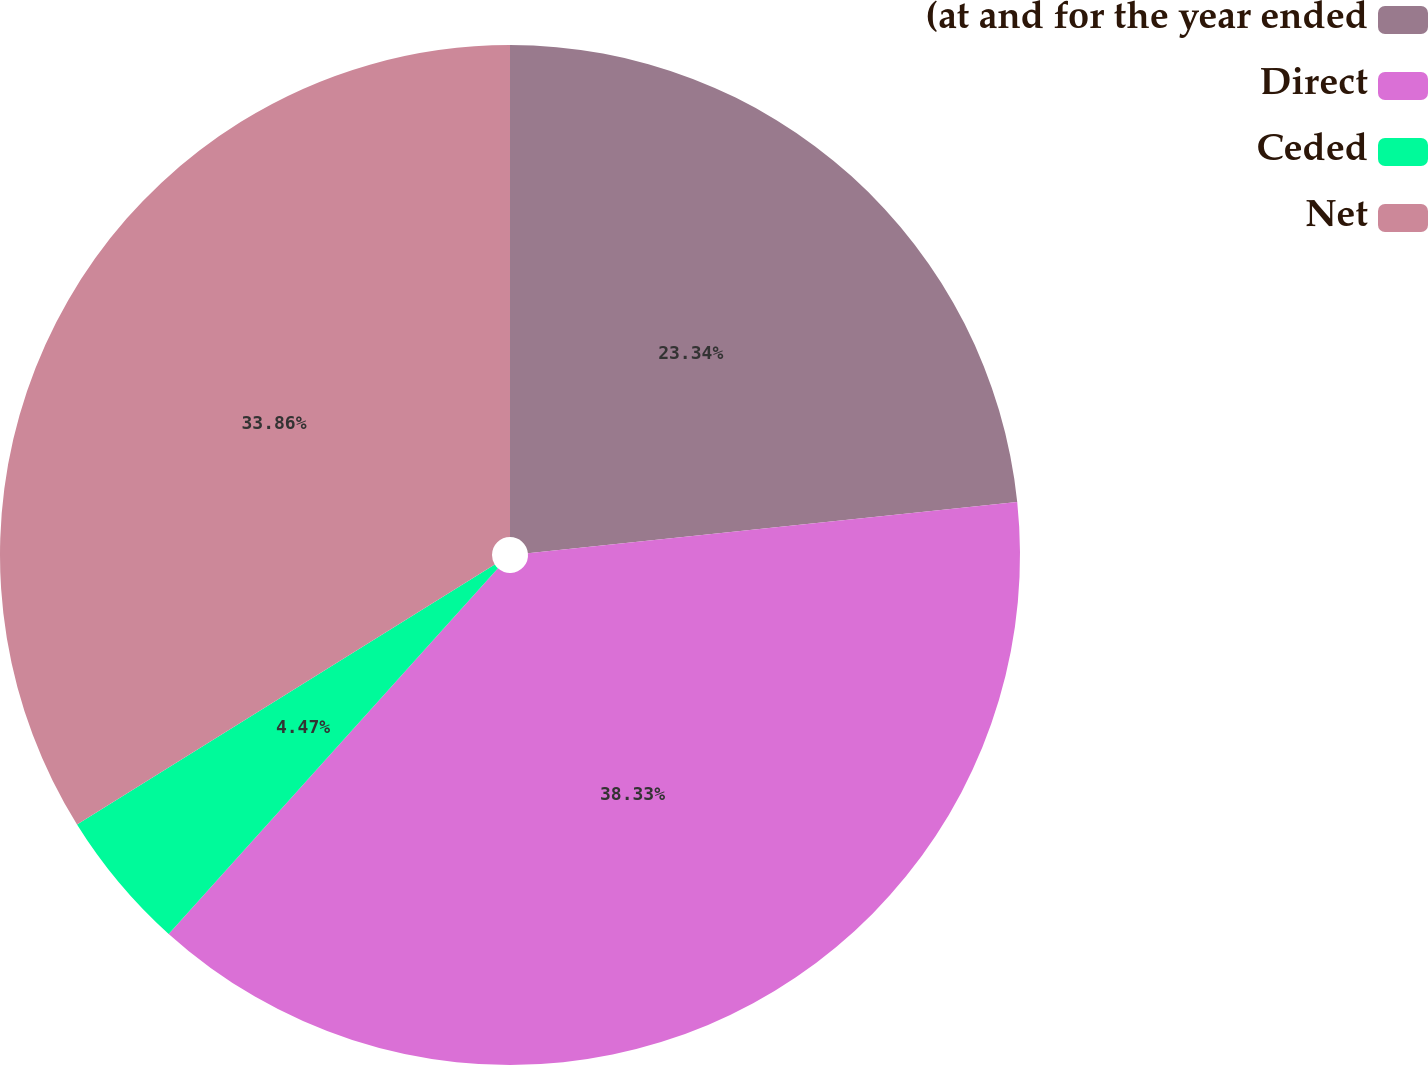Convert chart to OTSL. <chart><loc_0><loc_0><loc_500><loc_500><pie_chart><fcel>(at and for the year ended<fcel>Direct<fcel>Ceded<fcel>Net<nl><fcel>23.34%<fcel>38.33%<fcel>4.47%<fcel>33.86%<nl></chart> 